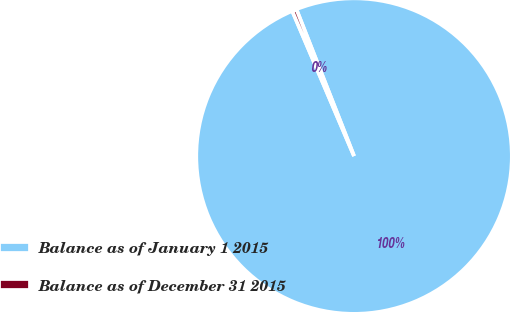<chart> <loc_0><loc_0><loc_500><loc_500><pie_chart><fcel>Balance as of January 1 2015<fcel>Balance as of December 31 2015<nl><fcel>99.55%<fcel>0.45%<nl></chart> 